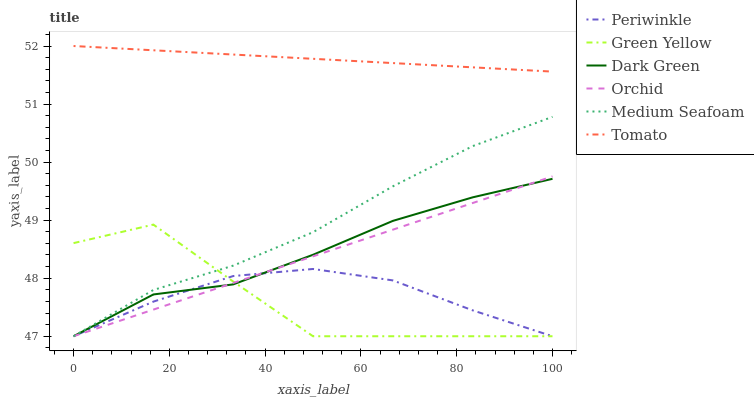Does Green Yellow have the minimum area under the curve?
Answer yes or no. Yes. Does Tomato have the maximum area under the curve?
Answer yes or no. Yes. Does Dark Green have the minimum area under the curve?
Answer yes or no. No. Does Dark Green have the maximum area under the curve?
Answer yes or no. No. Is Tomato the smoothest?
Answer yes or no. Yes. Is Green Yellow the roughest?
Answer yes or no. Yes. Is Dark Green the smoothest?
Answer yes or no. No. Is Dark Green the roughest?
Answer yes or no. No. Does Dark Green have the lowest value?
Answer yes or no. Yes. Does Tomato have the highest value?
Answer yes or no. Yes. Does Dark Green have the highest value?
Answer yes or no. No. Is Orchid less than Tomato?
Answer yes or no. Yes. Is Tomato greater than Dark Green?
Answer yes or no. Yes. Does Dark Green intersect Periwinkle?
Answer yes or no. Yes. Is Dark Green less than Periwinkle?
Answer yes or no. No. Is Dark Green greater than Periwinkle?
Answer yes or no. No. Does Orchid intersect Tomato?
Answer yes or no. No. 